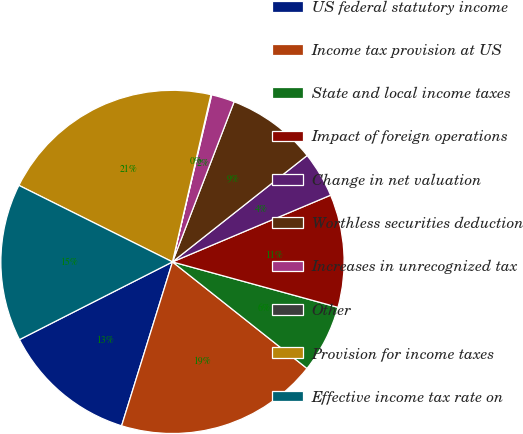Convert chart to OTSL. <chart><loc_0><loc_0><loc_500><loc_500><pie_chart><fcel>US federal statutory income<fcel>Income tax provision at US<fcel>State and local income taxes<fcel>Impact of foreign operations<fcel>Change in net valuation<fcel>Worthless securities deduction<fcel>Increases in unrecognized tax<fcel>Other<fcel>Provision for income taxes<fcel>Effective income tax rate on<nl><fcel>12.73%<fcel>19.13%<fcel>6.4%<fcel>10.62%<fcel>4.29%<fcel>8.51%<fcel>2.18%<fcel>0.07%<fcel>21.24%<fcel>14.84%<nl></chart> 